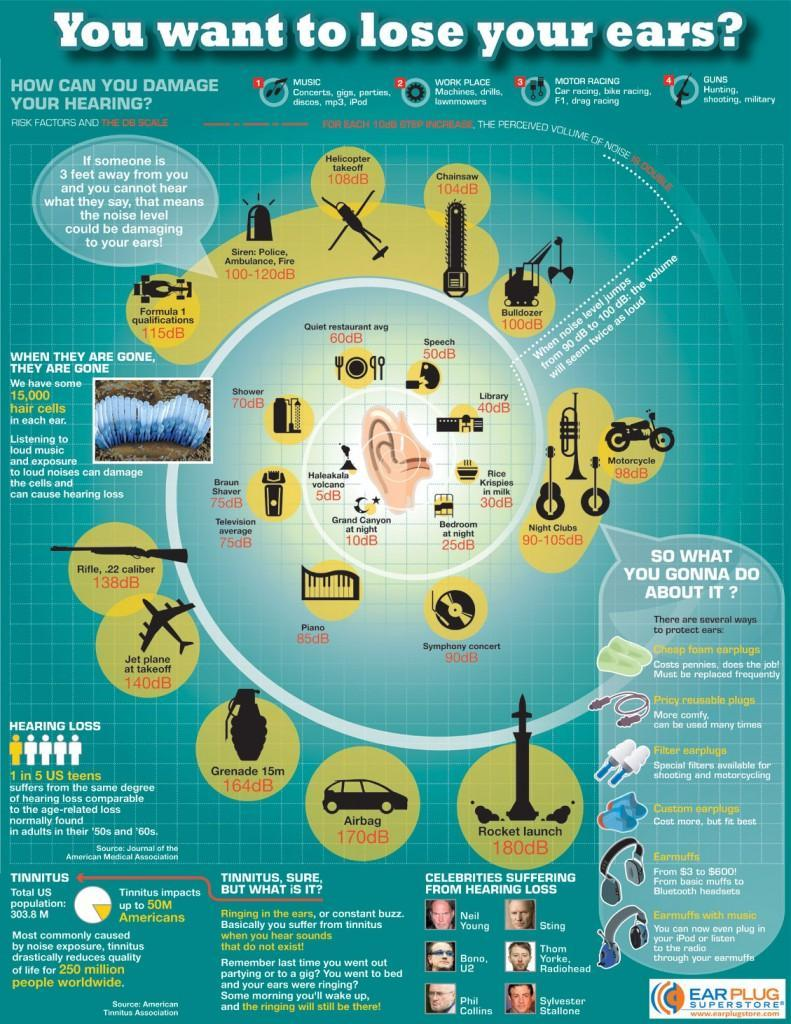In the image what produces a noise level of 170dB ?
Answer the question with a short phrase. Airbag What is the range of noise level at night clubs? 90-105dB What could happen if the hair cells are damaged by loud noises and loud music? Hearing loss What is the sound level at a library? 40dB What do Phil Collins and Sylvester Stallone suffer from? Hearing loss What is the level of noise produced when a chainsaw is operating? 104dB What condition causes you to hear sounds that don't exist? Tinnitus How many people are affected globally by tinnitus? 250 million What is the average sound level at the Grand Canyon at night? 10dB What is the cheapest way to protect ears from loud noises? Cheap foam earplugs 